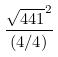Convert formula to latex. <formula><loc_0><loc_0><loc_500><loc_500>\frac { \sqrt { 4 4 1 } ^ { 2 } } { ( 4 / 4 ) }</formula> 